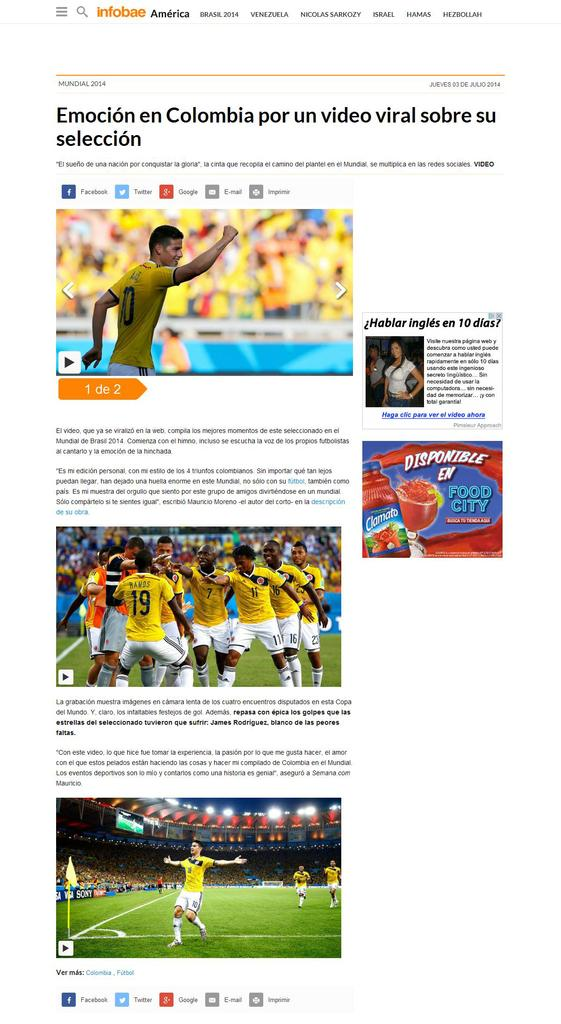Provide a one-sentence caption for the provided image. A picture of sports games with a headline that begins with the word Emocion. 